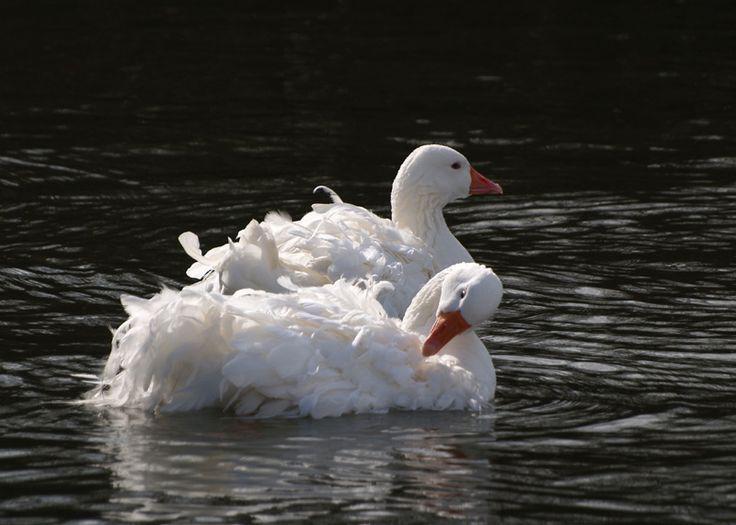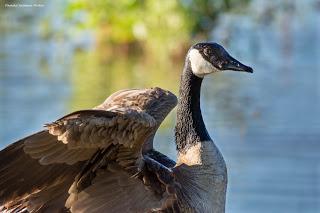The first image is the image on the left, the second image is the image on the right. Given the left and right images, does the statement "There are geese visible on the water" hold true? Answer yes or no. Yes. 